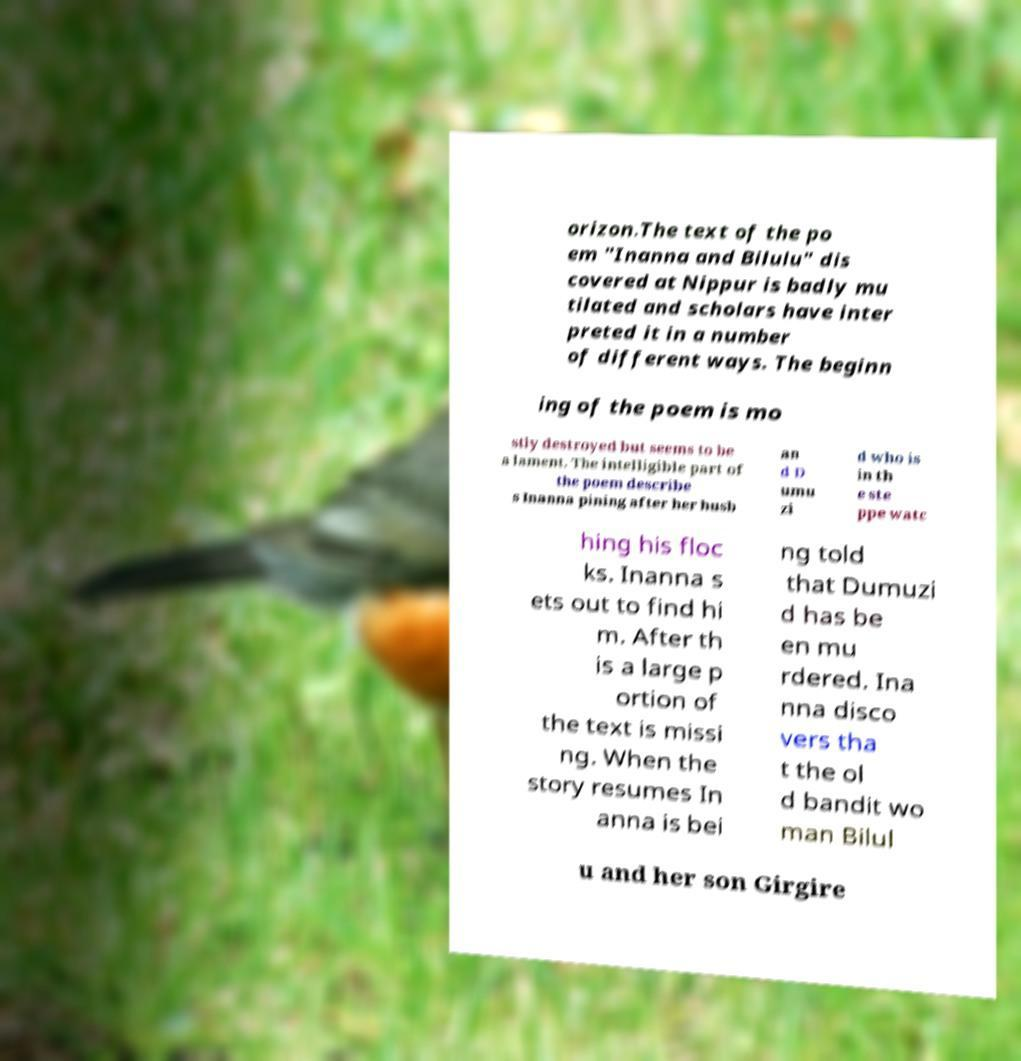Could you assist in decoding the text presented in this image and type it out clearly? orizon.The text of the po em "Inanna and Bilulu" dis covered at Nippur is badly mu tilated and scholars have inter preted it in a number of different ways. The beginn ing of the poem is mo stly destroyed but seems to be a lament. The intelligible part of the poem describe s Inanna pining after her husb an d D umu zi d who is in th e ste ppe watc hing his floc ks. Inanna s ets out to find hi m. After th is a large p ortion of the text is missi ng. When the story resumes In anna is bei ng told that Dumuzi d has be en mu rdered. Ina nna disco vers tha t the ol d bandit wo man Bilul u and her son Girgire 